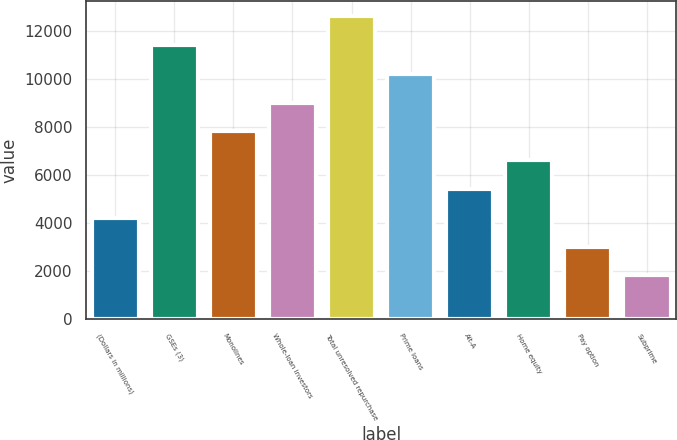Convert chart to OTSL. <chart><loc_0><loc_0><loc_500><loc_500><bar_chart><fcel>(Dollars in millions)<fcel>GSEs (3)<fcel>Monolines<fcel>Whole-loan investors<fcel>Total unresolved repurchase<fcel>Prime loans<fcel>Alt-A<fcel>Home equity<fcel>Pay option<fcel>Subprime<nl><fcel>4230.1<fcel>11410.3<fcel>7820.2<fcel>9016.9<fcel>12607<fcel>10213.6<fcel>5426.8<fcel>6623.5<fcel>3033.4<fcel>1836.7<nl></chart> 